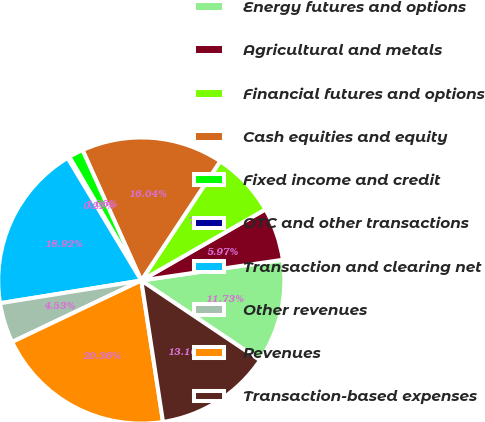Convert chart to OTSL. <chart><loc_0><loc_0><loc_500><loc_500><pie_chart><fcel>Energy futures and options<fcel>Agricultural and metals<fcel>Financial futures and options<fcel>Cash equities and equity<fcel>Fixed income and credit<fcel>OTC and other transactions<fcel>Transaction and clearing net<fcel>Other revenues<fcel>Revenues<fcel>Transaction-based expenses<nl><fcel>11.73%<fcel>5.97%<fcel>7.41%<fcel>16.04%<fcel>1.66%<fcel>0.22%<fcel>18.92%<fcel>4.53%<fcel>20.36%<fcel>13.16%<nl></chart> 